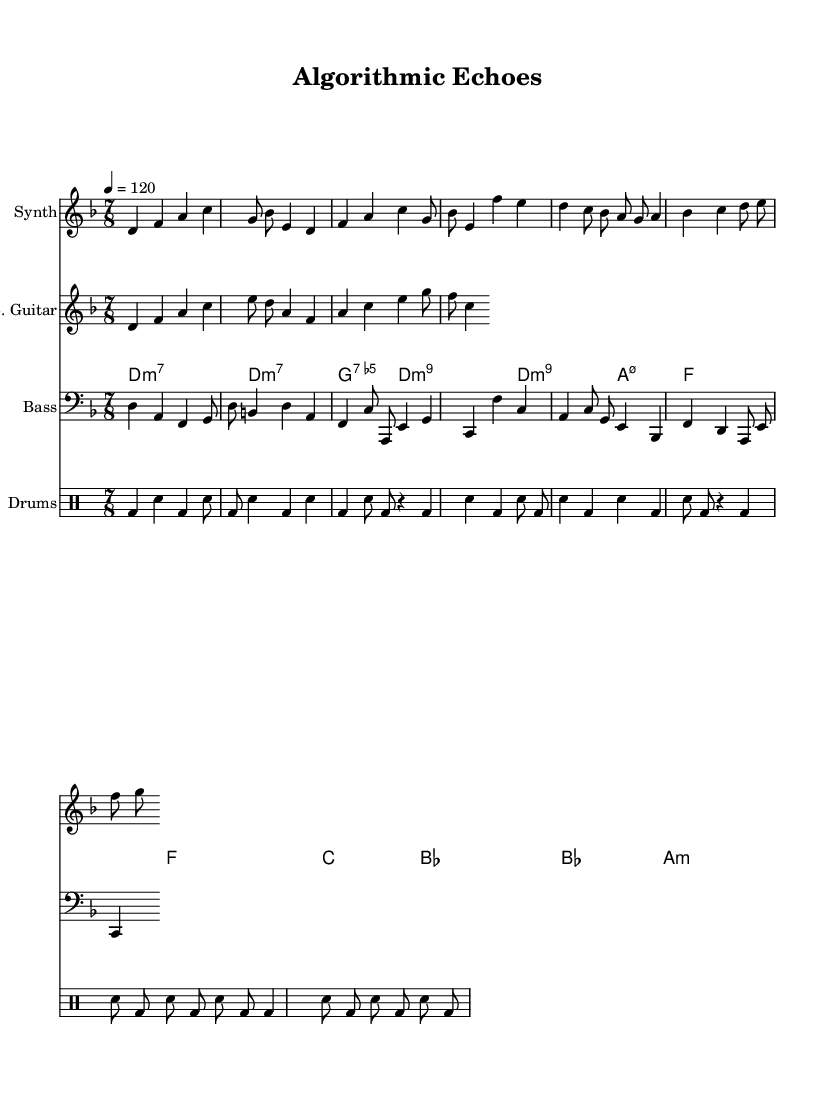What is the key signature of this music? The key signature is indicated at the start of the piece. The presence of one flat indicates the key of D minor.
Answer: D minor What is the time signature of the piece? The time signature is shown at the beginning of the score. It is expressed as a fraction with the upper number indicating beats per measure (7), and the lower number indicating the note value that receives one beat (8), thus showing a 7/8 time signature.
Answer: 7/8 What is the tempo marking for this music? The tempo marking is found near the beginning, indicating how fast the piece should be played. The marking reads "4 = 120," which means there are 120 quarter note beats per minute.
Answer: 120 How many measures are in the synth intro? To find the number of measures in the synth intro, we need to count the bar lines in the synthIntro section of the score. There are 2 measures shown.
Answer: 2 What is the chord for the guitar during the verse section? The chords for the guitar are indicated in the chordNames section. The guitar section during the verse shows the notes "d4 f a c e8 d a" representing a D minor tonality.
Answer: D minor How many times is the bass line repeated in the verse section? The bass line in the bassVerse is notated with 2 measures that appear to be played once each without any repeat signs indicating a continuous loop, allowing for a straightforward interpretation.
Answer: 2 Which percussion instrument is highlighted in the intro? The introduction includes a drum pattern specified in the 'drums' section. The notation indicates bass drum (bd) and snare drum (sn) patterns, which suggest the drums are featured prominently.
Answer: Drums 